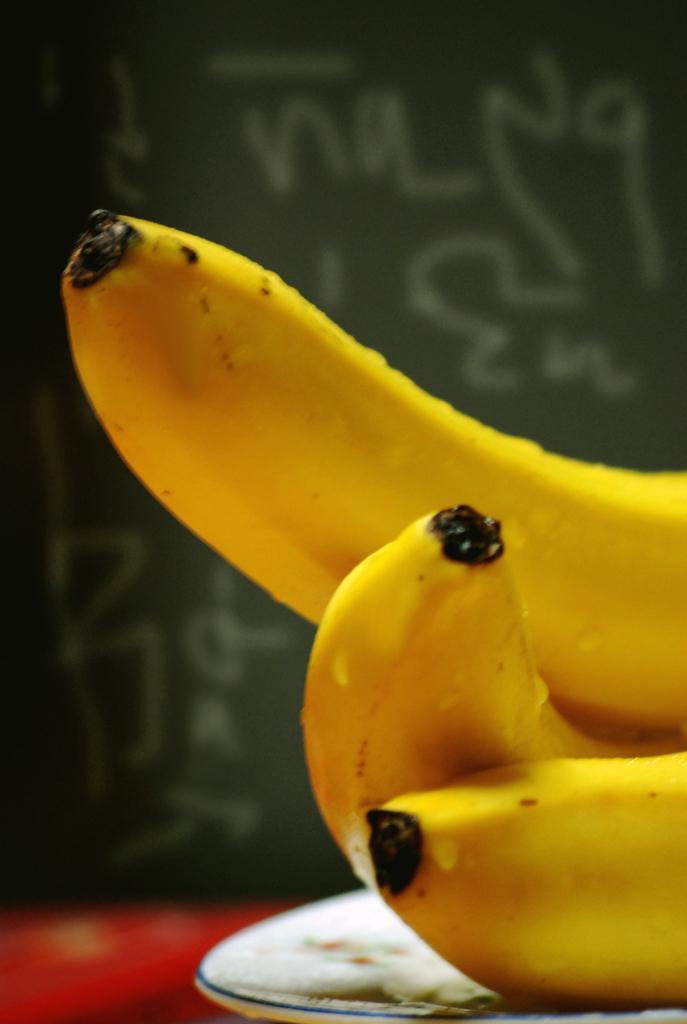In one or two sentences, can you explain what this image depicts? In this image, we can see some bananas on a plate is placed on the surface. In the background, we can see some text. 